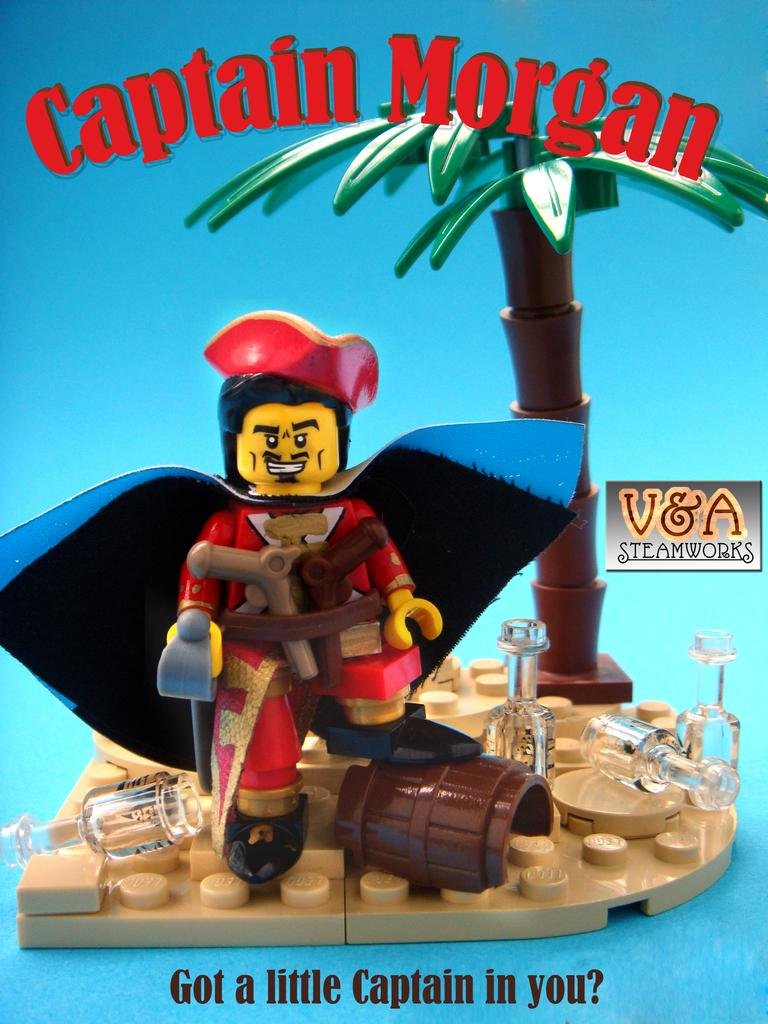What is featured on the poster in the image? There is a poster in the image, and it has a toy on it. Are there any other objects on the poster besides the toy? Yes, the poster has objects on it. What is the color of the poster's background? The poster has a blue background. Is there any text on the poster? Yes, there is text written on the poster. Can you see a man holding a light and wearing a mitten in the image? There is no man, light, or mitten present in the image; it only features a poster with a toy, objects, a blue background, and text. 